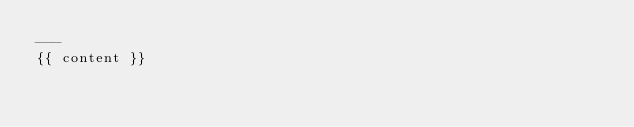Convert code to text. <code><loc_0><loc_0><loc_500><loc_500><_HTML_>---
{{ content }}
</code> 